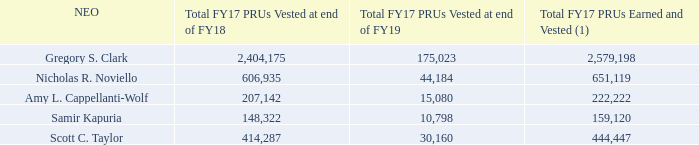Below is the summary of the FY17 PRUs vested and earned by each NEO.
(1) The Compensation Committee did not exercise its discretion to reduce any payouts.
Were any payouts reduced by the Compensation Committee? The compensation committee did not exercise its discretion to reduce any payouts. What does the table show? Summary of the fy17 prus vested and earned by each neo. What is the Total FY17 PRUs Earned and Vested for  Gregory S. Clark? 2,579,198. What is the difference between Total FY17 PRUs Earned and Vested between Gregory S. Clark and  Nicholas R. Noviello? 2,579,198-651,119
Answer: 1928079. What is the total Total FY17 PRUs Earned and Vested for all NEOs? 2,579,198+651,119+222,222+159,120+444,447
Answer: 4056106. What is the average Total FY17 PRUs Earned and Vested for all NEOs? (2,579,198+651,119+222,222+159,120+444,447)/5
Answer: 811221.2. 